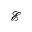Convert formula to latex. <formula><loc_0><loc_0><loc_500><loc_500>\mathcal { E }</formula> 